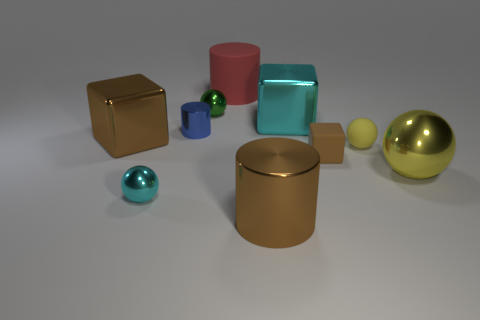Subtract all cubes. How many objects are left? 7 Subtract 0 yellow blocks. How many objects are left? 10 Subtract all tiny yellow things. Subtract all large brown metallic cylinders. How many objects are left? 8 Add 2 cyan metallic balls. How many cyan metallic balls are left? 3 Add 9 small cyan cubes. How many small cyan cubes exist? 9 